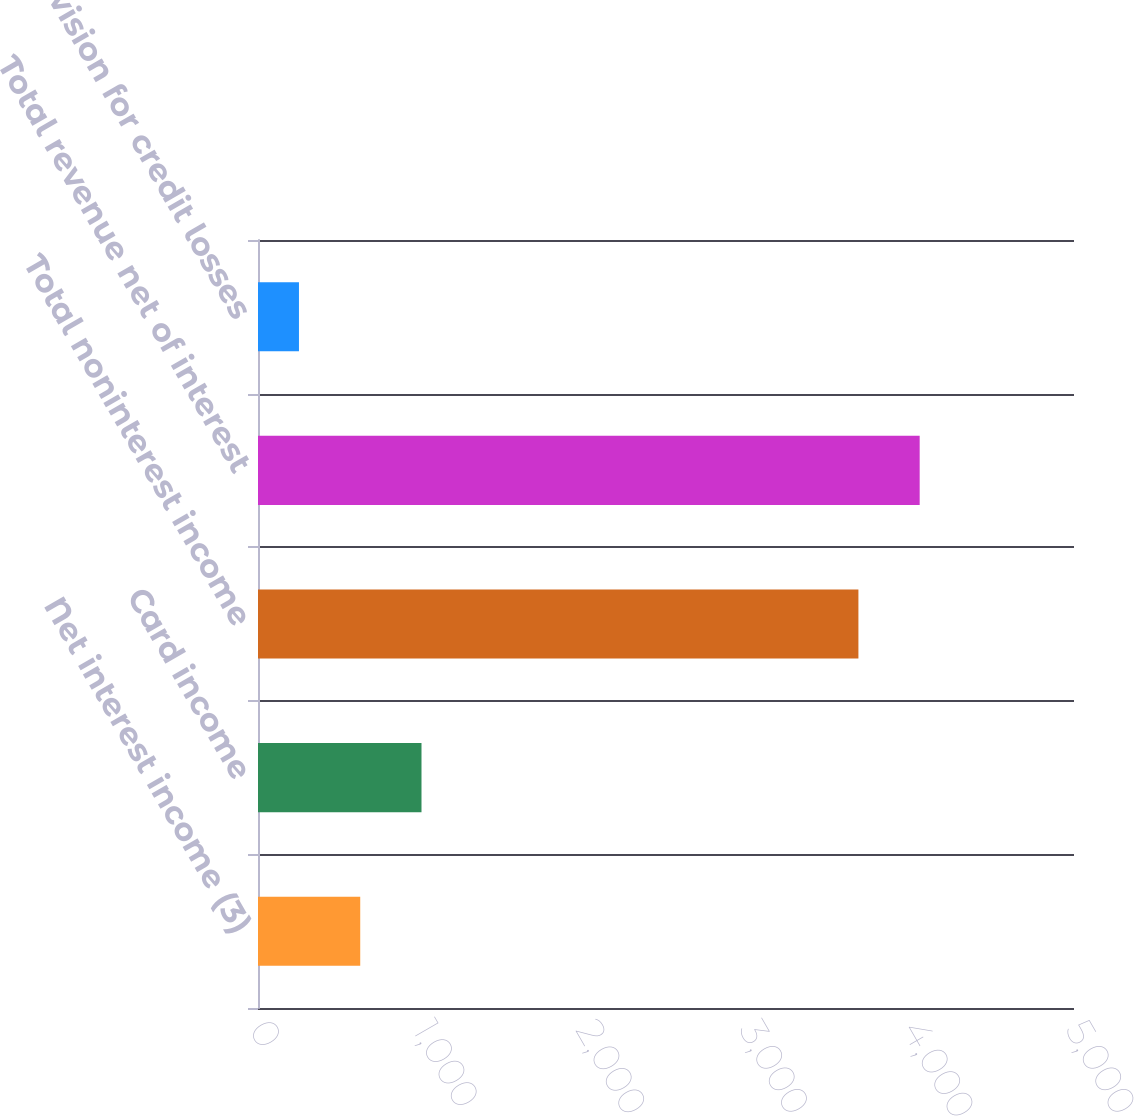Convert chart to OTSL. <chart><loc_0><loc_0><loc_500><loc_500><bar_chart><fcel>Net interest income (3)<fcel>Card income<fcel>Total noninterest income<fcel>Total revenue net of interest<fcel>Provision for credit losses<nl><fcel>626.4<fcel>1001.8<fcel>3679<fcel>4054.4<fcel>251<nl></chart> 